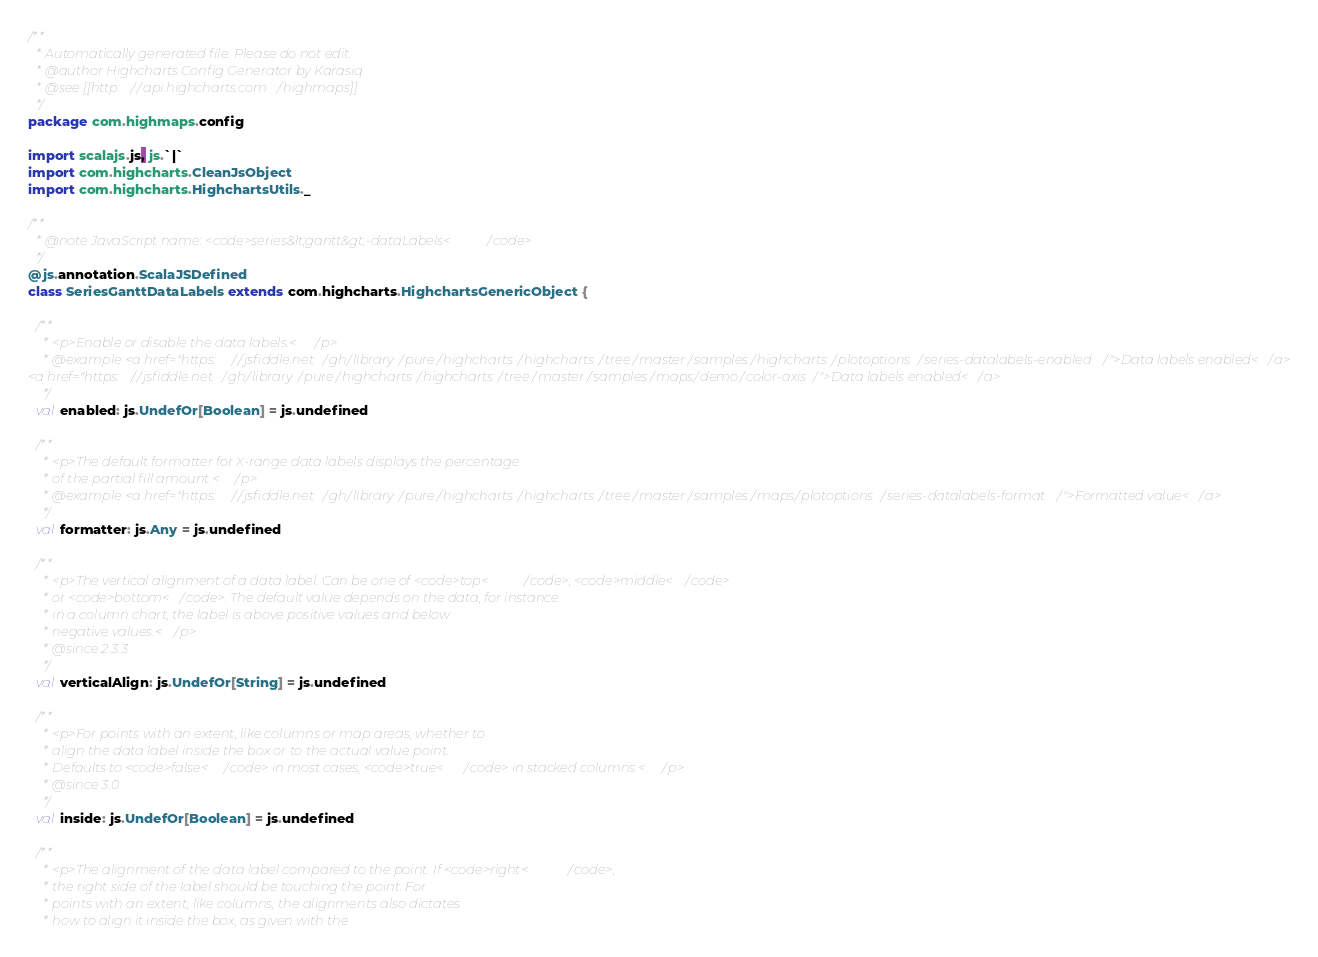<code> <loc_0><loc_0><loc_500><loc_500><_Scala_>/**
  * Automatically generated file. Please do not edit.
  * @author Highcharts Config Generator by Karasiq
  * @see [[http://api.highcharts.com/highmaps]]
  */
package com.highmaps.config

import scalajs.js, js.`|`
import com.highcharts.CleanJsObject
import com.highcharts.HighchartsUtils._

/**
  * @note JavaScript name: <code>series&lt;gantt&gt;-dataLabels</code>
  */
@js.annotation.ScalaJSDefined
class SeriesGanttDataLabels extends com.highcharts.HighchartsGenericObject {

  /**
    * <p>Enable or disable the data labels.</p>
    * @example <a href="https://jsfiddle.net/gh/library/pure/highcharts/highcharts/tree/master/samples/highcharts/plotoptions/series-datalabels-enabled/">Data labels enabled</a>
<a href="https://jsfiddle.net/gh/library/pure/highcharts/highcharts/tree/master/samples/maps/demo/color-axis/">Data labels enabled</a>
    */
  val enabled: js.UndefOr[Boolean] = js.undefined

  /**
    * <p>The default formatter for X-range data labels displays the percentage
    * of the partial fill amount.</p>
    * @example <a href="https://jsfiddle.net/gh/library/pure/highcharts/highcharts/tree/master/samples/maps/plotoptions/series-datalabels-format/">Formatted value</a>
    */
  val formatter: js.Any = js.undefined

  /**
    * <p>The vertical alignment of a data label. Can be one of <code>top</code>, <code>middle</code>
    * or <code>bottom</code>. The default value depends on the data, for instance
    * in a column chart, the label is above positive values and below
    * negative values.</p>
    * @since 2.3.3
    */
  val verticalAlign: js.UndefOr[String] = js.undefined

  /**
    * <p>For points with an extent, like columns or map areas, whether to
    * align the data label inside the box or to the actual value point.
    * Defaults to <code>false</code> in most cases, <code>true</code> in stacked columns.</p>
    * @since 3.0
    */
  val inside: js.UndefOr[Boolean] = js.undefined

  /**
    * <p>The alignment of the data label compared to the point. If <code>right</code>,
    * the right side of the label should be touching the point. For
    * points with an extent, like columns, the alignments also dictates
    * how to align it inside the box, as given with the</code> 